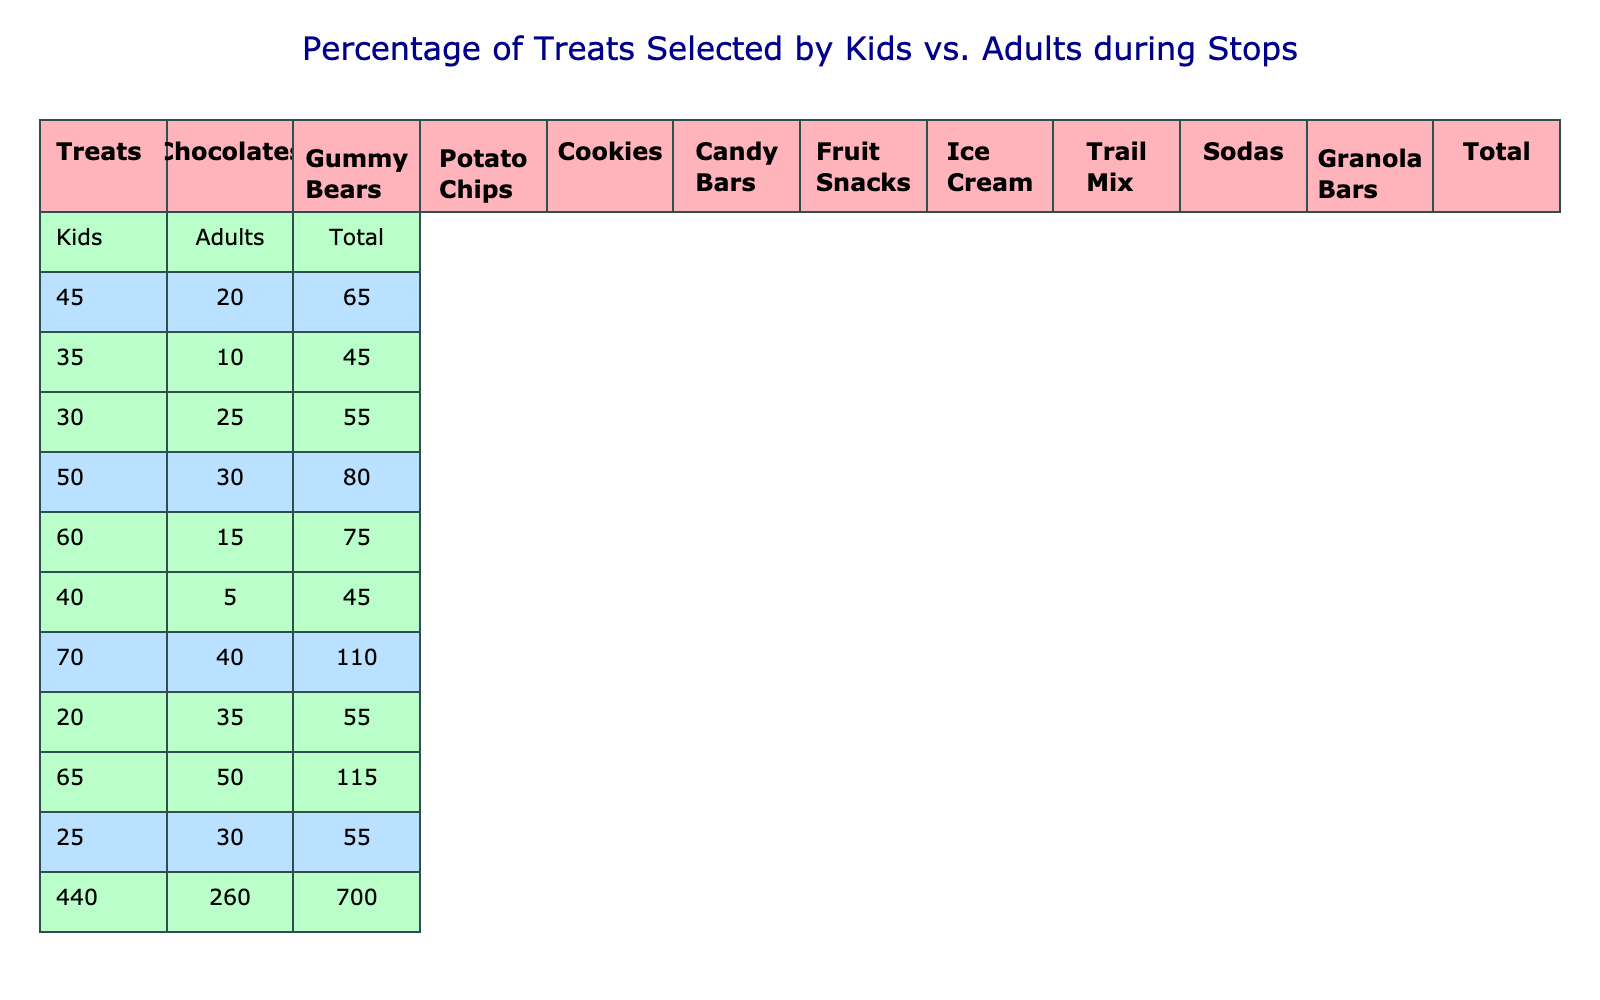What treat did kids prefer the most? From the table, we can see that Ice Cream has the highest percentage selected by kids at 70%.
Answer: Ice Cream Which treat did adults choose the least? Looking at the Adults column, Fruit Snacks has the lowest percentage at 5%.
Answer: Fruit Snacks What is the total percentage of treats selected by adults? To find this, we sum the Adults column: 20 + 10 + 25 + 30 + 15 + 5 + 40 + 35 + 50 + 30 =  5
Answer: 5 Did kids select more Cookies than Adults? The percentage of Cookies selected by kids is 50%, while adults selected only 30%. Since 50% is greater than 30%, the statement is true.
Answer: Yes What is the average percentage of treats selected by kids? We sum the percentages selected by kids: 45 + 35 + 30 + 50 + 60 + 40 + 70 + 20 + 65 + 25 =  70; there are 10 treats, so we divide by 10 to find the average:  70 / 10 = 47%.
Answer: 47% Which group selected more of Potato Chips? The percentage of Potato Chips selected by kids is 30%, while adults selected 25%. Since 30% is greater than 25%, kids selected more.
Answer: Kids Are Sodas selected more by adults than Gummy Bears by kids? The percentage of Sodas selected by adults is 50%, while Gummy Bears was selected by kids at 35%. Since 50% is greater than 35%, the statement is true.
Answer: Yes What is the difference in percentage selection between Ice Cream for kids and Granola Bars for adults? Ice Cream for kids is selected at 70%, while Granola Bars for adults are selected at 30%. To find the difference, we subtract 30% from 70%, which gives us 40%.
Answer: 40% What is the total percentage of all treats selected by kids? We add all the values in the Kids column: 45 + 35 + 30 + 50 + 60 + 40 + 70 + 20 + 65 + 25 =  70.
Answer: 70 